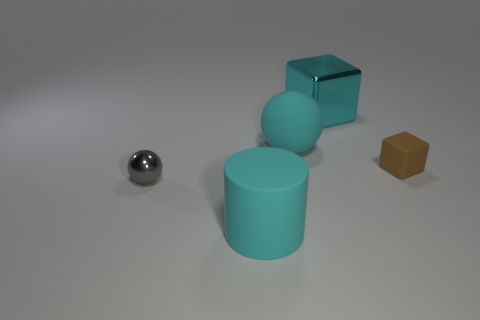Can you guess the purpose of this arrangement of objects? This arrangement of objects might be a visual composition intended to study shapes, colors, and material properties, perhaps for an art project or a 3D modeling exercise. 